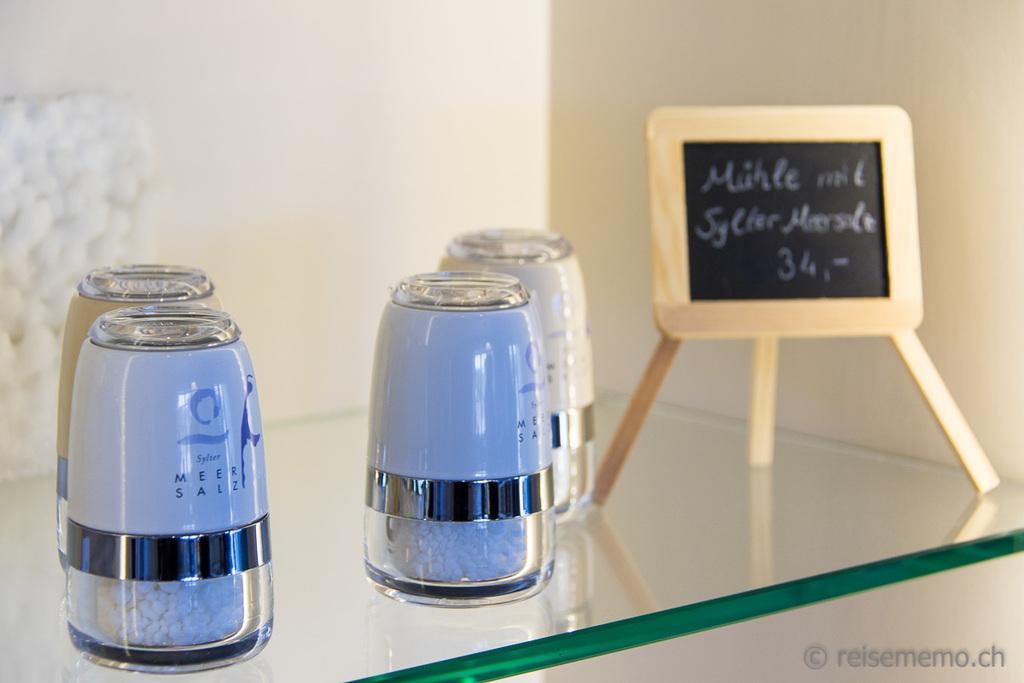Could you give a brief overview of what you see in this image? In the image in the center, we can see one glass table. On the table, we can see one slate, stand and jars. And we can see something written on the slate. In the bottom right of the image, there is a watermark. In the background there is a wall. 